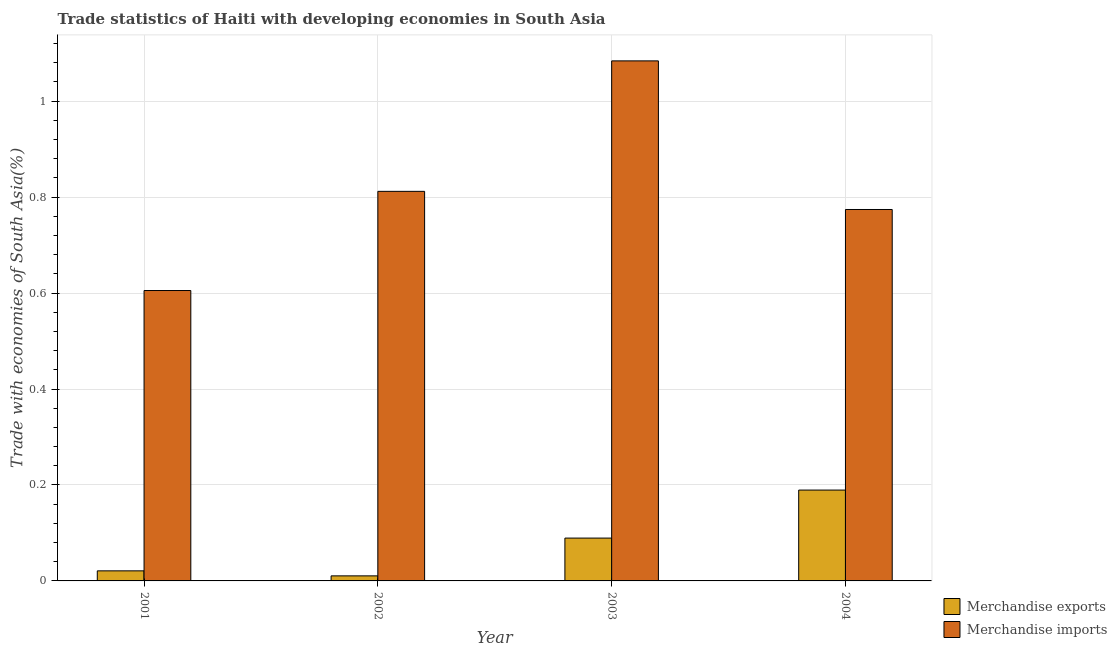How many groups of bars are there?
Your answer should be compact. 4. Are the number of bars per tick equal to the number of legend labels?
Your answer should be very brief. Yes. Are the number of bars on each tick of the X-axis equal?
Ensure brevity in your answer.  Yes. How many bars are there on the 1st tick from the right?
Provide a succinct answer. 2. In how many cases, is the number of bars for a given year not equal to the number of legend labels?
Ensure brevity in your answer.  0. What is the merchandise exports in 2001?
Provide a short and direct response. 0.02. Across all years, what is the maximum merchandise exports?
Your response must be concise. 0.19. Across all years, what is the minimum merchandise imports?
Offer a very short reply. 0.61. In which year was the merchandise exports minimum?
Offer a terse response. 2002. What is the total merchandise exports in the graph?
Provide a succinct answer. 0.31. What is the difference between the merchandise exports in 2001 and that in 2003?
Keep it short and to the point. -0.07. What is the difference between the merchandise exports in 2003 and the merchandise imports in 2004?
Your response must be concise. -0.1. What is the average merchandise imports per year?
Provide a short and direct response. 0.82. In how many years, is the merchandise imports greater than 0.88 %?
Provide a short and direct response. 1. What is the ratio of the merchandise exports in 2001 to that in 2003?
Provide a succinct answer. 0.23. What is the difference between the highest and the second highest merchandise exports?
Your response must be concise. 0.1. What is the difference between the highest and the lowest merchandise imports?
Ensure brevity in your answer.  0.48. Is the sum of the merchandise imports in 2001 and 2003 greater than the maximum merchandise exports across all years?
Give a very brief answer. Yes. What does the 2nd bar from the left in 2004 represents?
Your answer should be compact. Merchandise imports. What does the 2nd bar from the right in 2003 represents?
Give a very brief answer. Merchandise exports. What is the difference between two consecutive major ticks on the Y-axis?
Your answer should be compact. 0.2. Are the values on the major ticks of Y-axis written in scientific E-notation?
Your answer should be very brief. No. Does the graph contain grids?
Keep it short and to the point. Yes. How are the legend labels stacked?
Keep it short and to the point. Vertical. What is the title of the graph?
Offer a very short reply. Trade statistics of Haiti with developing economies in South Asia. What is the label or title of the X-axis?
Your answer should be compact. Year. What is the label or title of the Y-axis?
Your answer should be very brief. Trade with economies of South Asia(%). What is the Trade with economies of South Asia(%) of Merchandise exports in 2001?
Provide a short and direct response. 0.02. What is the Trade with economies of South Asia(%) of Merchandise imports in 2001?
Offer a very short reply. 0.61. What is the Trade with economies of South Asia(%) of Merchandise exports in 2002?
Provide a short and direct response. 0.01. What is the Trade with economies of South Asia(%) of Merchandise imports in 2002?
Make the answer very short. 0.81. What is the Trade with economies of South Asia(%) in Merchandise exports in 2003?
Keep it short and to the point. 0.09. What is the Trade with economies of South Asia(%) in Merchandise imports in 2003?
Give a very brief answer. 1.08. What is the Trade with economies of South Asia(%) in Merchandise exports in 2004?
Keep it short and to the point. 0.19. What is the Trade with economies of South Asia(%) in Merchandise imports in 2004?
Your answer should be compact. 0.77. Across all years, what is the maximum Trade with economies of South Asia(%) in Merchandise exports?
Offer a very short reply. 0.19. Across all years, what is the maximum Trade with economies of South Asia(%) in Merchandise imports?
Your answer should be compact. 1.08. Across all years, what is the minimum Trade with economies of South Asia(%) in Merchandise exports?
Keep it short and to the point. 0.01. Across all years, what is the minimum Trade with economies of South Asia(%) of Merchandise imports?
Your response must be concise. 0.61. What is the total Trade with economies of South Asia(%) in Merchandise exports in the graph?
Provide a short and direct response. 0.31. What is the total Trade with economies of South Asia(%) in Merchandise imports in the graph?
Your answer should be compact. 3.28. What is the difference between the Trade with economies of South Asia(%) in Merchandise exports in 2001 and that in 2002?
Your answer should be very brief. 0.01. What is the difference between the Trade with economies of South Asia(%) in Merchandise imports in 2001 and that in 2002?
Offer a very short reply. -0.21. What is the difference between the Trade with economies of South Asia(%) in Merchandise exports in 2001 and that in 2003?
Keep it short and to the point. -0.07. What is the difference between the Trade with economies of South Asia(%) of Merchandise imports in 2001 and that in 2003?
Ensure brevity in your answer.  -0.48. What is the difference between the Trade with economies of South Asia(%) in Merchandise exports in 2001 and that in 2004?
Your response must be concise. -0.17. What is the difference between the Trade with economies of South Asia(%) in Merchandise imports in 2001 and that in 2004?
Keep it short and to the point. -0.17. What is the difference between the Trade with economies of South Asia(%) in Merchandise exports in 2002 and that in 2003?
Offer a very short reply. -0.08. What is the difference between the Trade with economies of South Asia(%) in Merchandise imports in 2002 and that in 2003?
Make the answer very short. -0.27. What is the difference between the Trade with economies of South Asia(%) of Merchandise exports in 2002 and that in 2004?
Give a very brief answer. -0.18. What is the difference between the Trade with economies of South Asia(%) of Merchandise imports in 2002 and that in 2004?
Your response must be concise. 0.04. What is the difference between the Trade with economies of South Asia(%) in Merchandise exports in 2003 and that in 2004?
Your answer should be very brief. -0.1. What is the difference between the Trade with economies of South Asia(%) of Merchandise imports in 2003 and that in 2004?
Provide a succinct answer. 0.31. What is the difference between the Trade with economies of South Asia(%) in Merchandise exports in 2001 and the Trade with economies of South Asia(%) in Merchandise imports in 2002?
Your answer should be compact. -0.79. What is the difference between the Trade with economies of South Asia(%) of Merchandise exports in 2001 and the Trade with economies of South Asia(%) of Merchandise imports in 2003?
Your response must be concise. -1.06. What is the difference between the Trade with economies of South Asia(%) of Merchandise exports in 2001 and the Trade with economies of South Asia(%) of Merchandise imports in 2004?
Provide a short and direct response. -0.75. What is the difference between the Trade with economies of South Asia(%) of Merchandise exports in 2002 and the Trade with economies of South Asia(%) of Merchandise imports in 2003?
Ensure brevity in your answer.  -1.07. What is the difference between the Trade with economies of South Asia(%) in Merchandise exports in 2002 and the Trade with economies of South Asia(%) in Merchandise imports in 2004?
Provide a succinct answer. -0.76. What is the difference between the Trade with economies of South Asia(%) of Merchandise exports in 2003 and the Trade with economies of South Asia(%) of Merchandise imports in 2004?
Offer a very short reply. -0.68. What is the average Trade with economies of South Asia(%) of Merchandise exports per year?
Your response must be concise. 0.08. What is the average Trade with economies of South Asia(%) in Merchandise imports per year?
Provide a short and direct response. 0.82. In the year 2001, what is the difference between the Trade with economies of South Asia(%) in Merchandise exports and Trade with economies of South Asia(%) in Merchandise imports?
Offer a very short reply. -0.58. In the year 2002, what is the difference between the Trade with economies of South Asia(%) of Merchandise exports and Trade with economies of South Asia(%) of Merchandise imports?
Ensure brevity in your answer.  -0.8. In the year 2003, what is the difference between the Trade with economies of South Asia(%) in Merchandise exports and Trade with economies of South Asia(%) in Merchandise imports?
Your response must be concise. -0.99. In the year 2004, what is the difference between the Trade with economies of South Asia(%) of Merchandise exports and Trade with economies of South Asia(%) of Merchandise imports?
Ensure brevity in your answer.  -0.58. What is the ratio of the Trade with economies of South Asia(%) in Merchandise exports in 2001 to that in 2002?
Offer a very short reply. 1.99. What is the ratio of the Trade with economies of South Asia(%) in Merchandise imports in 2001 to that in 2002?
Provide a short and direct response. 0.75. What is the ratio of the Trade with economies of South Asia(%) of Merchandise exports in 2001 to that in 2003?
Your answer should be compact. 0.23. What is the ratio of the Trade with economies of South Asia(%) of Merchandise imports in 2001 to that in 2003?
Offer a very short reply. 0.56. What is the ratio of the Trade with economies of South Asia(%) of Merchandise exports in 2001 to that in 2004?
Ensure brevity in your answer.  0.11. What is the ratio of the Trade with economies of South Asia(%) in Merchandise imports in 2001 to that in 2004?
Your answer should be very brief. 0.78. What is the ratio of the Trade with economies of South Asia(%) of Merchandise exports in 2002 to that in 2003?
Provide a succinct answer. 0.12. What is the ratio of the Trade with economies of South Asia(%) of Merchandise imports in 2002 to that in 2003?
Keep it short and to the point. 0.75. What is the ratio of the Trade with economies of South Asia(%) of Merchandise exports in 2002 to that in 2004?
Give a very brief answer. 0.06. What is the ratio of the Trade with economies of South Asia(%) of Merchandise imports in 2002 to that in 2004?
Ensure brevity in your answer.  1.05. What is the ratio of the Trade with economies of South Asia(%) of Merchandise exports in 2003 to that in 2004?
Offer a terse response. 0.47. What is the ratio of the Trade with economies of South Asia(%) of Merchandise imports in 2003 to that in 2004?
Ensure brevity in your answer.  1.4. What is the difference between the highest and the second highest Trade with economies of South Asia(%) of Merchandise exports?
Give a very brief answer. 0.1. What is the difference between the highest and the second highest Trade with economies of South Asia(%) in Merchandise imports?
Provide a short and direct response. 0.27. What is the difference between the highest and the lowest Trade with economies of South Asia(%) of Merchandise exports?
Provide a succinct answer. 0.18. What is the difference between the highest and the lowest Trade with economies of South Asia(%) in Merchandise imports?
Give a very brief answer. 0.48. 